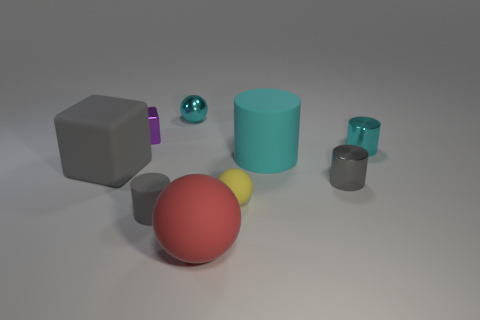There is a cyan matte object; are there any big cyan matte objects in front of it?
Your answer should be compact. No. Does the shiny ball have the same size as the red thing?
Keep it short and to the point. No. The gray rubber thing on the right side of the large gray block has what shape?
Provide a short and direct response. Cylinder. Is there a red matte object of the same size as the gray rubber cylinder?
Your answer should be very brief. No. What is the material of the ball that is the same size as the gray rubber block?
Provide a succinct answer. Rubber. What is the size of the shiny thing that is on the left side of the tiny cyan sphere?
Provide a short and direct response. Small. What size is the red matte ball?
Offer a terse response. Large. Does the cyan ball have the same size as the gray cylinder that is on the left side of the large red matte sphere?
Your answer should be very brief. Yes. The cylinder right of the tiny gray thing that is to the right of the cyan sphere is what color?
Provide a short and direct response. Cyan. Are there an equal number of gray rubber cylinders that are behind the yellow object and metal cylinders on the left side of the tiny purple metal thing?
Make the answer very short. Yes. 